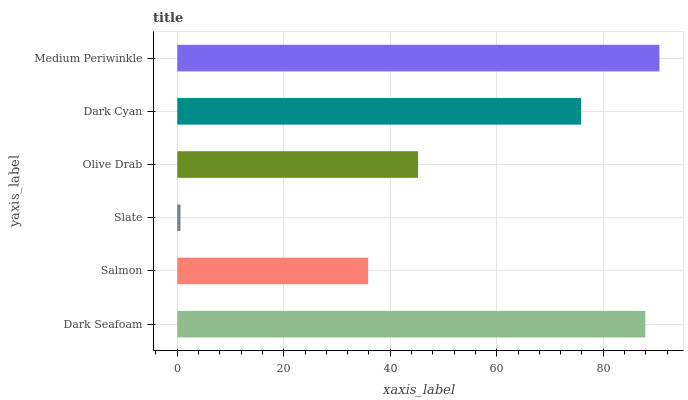Is Slate the minimum?
Answer yes or no. Yes. Is Medium Periwinkle the maximum?
Answer yes or no. Yes. Is Salmon the minimum?
Answer yes or no. No. Is Salmon the maximum?
Answer yes or no. No. Is Dark Seafoam greater than Salmon?
Answer yes or no. Yes. Is Salmon less than Dark Seafoam?
Answer yes or no. Yes. Is Salmon greater than Dark Seafoam?
Answer yes or no. No. Is Dark Seafoam less than Salmon?
Answer yes or no. No. Is Dark Cyan the high median?
Answer yes or no. Yes. Is Olive Drab the low median?
Answer yes or no. Yes. Is Medium Periwinkle the high median?
Answer yes or no. No. Is Salmon the low median?
Answer yes or no. No. 